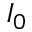Convert formula to latex. <formula><loc_0><loc_0><loc_500><loc_500>I _ { 0 }</formula> 